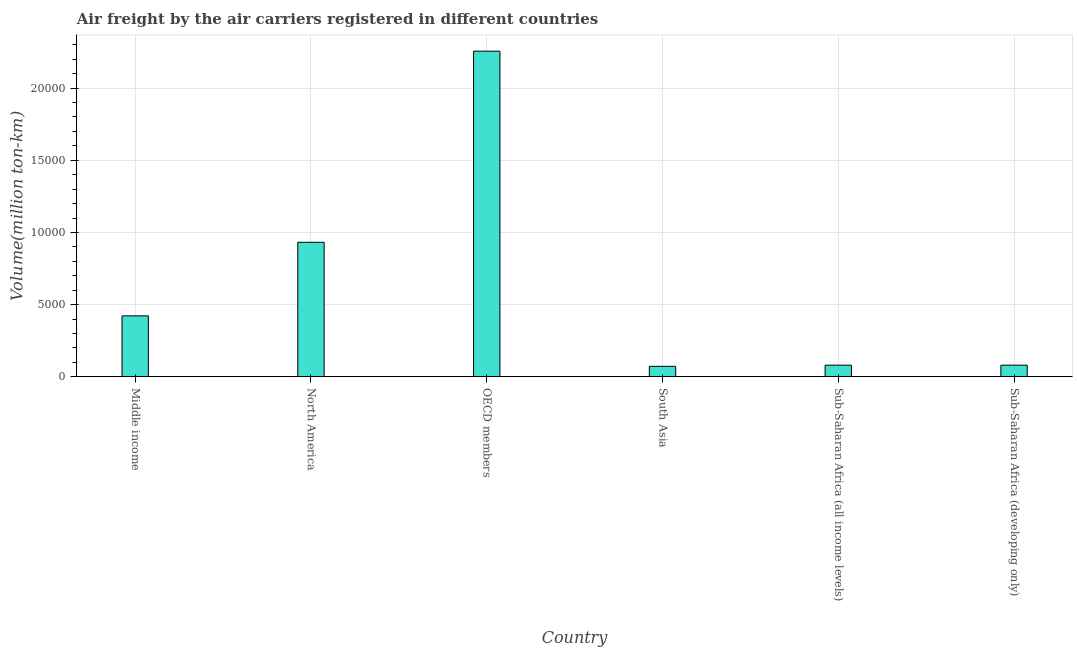Does the graph contain any zero values?
Provide a short and direct response. No. Does the graph contain grids?
Your answer should be very brief. Yes. What is the title of the graph?
Offer a terse response. Air freight by the air carriers registered in different countries. What is the label or title of the X-axis?
Your response must be concise. Country. What is the label or title of the Y-axis?
Provide a succinct answer. Volume(million ton-km). What is the air freight in Sub-Saharan Africa (developing only)?
Offer a terse response. 810.7. Across all countries, what is the maximum air freight?
Offer a terse response. 2.26e+04. Across all countries, what is the minimum air freight?
Keep it short and to the point. 729.2. In which country was the air freight maximum?
Keep it short and to the point. OECD members. In which country was the air freight minimum?
Make the answer very short. South Asia. What is the sum of the air freight?
Make the answer very short. 3.85e+04. What is the difference between the air freight in OECD members and Sub-Saharan Africa (developing only)?
Provide a short and direct response. 2.17e+04. What is the average air freight per country?
Your response must be concise. 6408.45. What is the median air freight?
Make the answer very short. 2517.85. What is the ratio of the air freight in Middle income to that in Sub-Saharan Africa (all income levels)?
Keep it short and to the point. 5.21. Is the air freight in Middle income less than that in North America?
Provide a succinct answer. Yes. Is the difference between the air freight in North America and South Asia greater than the difference between any two countries?
Give a very brief answer. No. What is the difference between the highest and the second highest air freight?
Keep it short and to the point. 1.32e+04. What is the difference between the highest and the lowest air freight?
Your answer should be compact. 2.18e+04. How many bars are there?
Give a very brief answer. 6. How many countries are there in the graph?
Provide a succinct answer. 6. Are the values on the major ticks of Y-axis written in scientific E-notation?
Ensure brevity in your answer.  No. What is the Volume(million ton-km) of Middle income?
Your answer should be very brief. 4224.9. What is the Volume(million ton-km) in North America?
Offer a terse response. 9320. What is the Volume(million ton-km) of OECD members?
Give a very brief answer. 2.26e+04. What is the Volume(million ton-km) in South Asia?
Keep it short and to the point. 729.2. What is the Volume(million ton-km) in Sub-Saharan Africa (all income levels)?
Offer a very short reply. 810.8. What is the Volume(million ton-km) of Sub-Saharan Africa (developing only)?
Keep it short and to the point. 810.7. What is the difference between the Volume(million ton-km) in Middle income and North America?
Ensure brevity in your answer.  -5095.1. What is the difference between the Volume(million ton-km) in Middle income and OECD members?
Your response must be concise. -1.83e+04. What is the difference between the Volume(million ton-km) in Middle income and South Asia?
Offer a terse response. 3495.7. What is the difference between the Volume(million ton-km) in Middle income and Sub-Saharan Africa (all income levels)?
Ensure brevity in your answer.  3414.1. What is the difference between the Volume(million ton-km) in Middle income and Sub-Saharan Africa (developing only)?
Keep it short and to the point. 3414.2. What is the difference between the Volume(million ton-km) in North America and OECD members?
Provide a short and direct response. -1.32e+04. What is the difference between the Volume(million ton-km) in North America and South Asia?
Provide a short and direct response. 8590.8. What is the difference between the Volume(million ton-km) in North America and Sub-Saharan Africa (all income levels)?
Provide a short and direct response. 8509.2. What is the difference between the Volume(million ton-km) in North America and Sub-Saharan Africa (developing only)?
Provide a succinct answer. 8509.3. What is the difference between the Volume(million ton-km) in OECD members and South Asia?
Make the answer very short. 2.18e+04. What is the difference between the Volume(million ton-km) in OECD members and Sub-Saharan Africa (all income levels)?
Your answer should be very brief. 2.17e+04. What is the difference between the Volume(million ton-km) in OECD members and Sub-Saharan Africa (developing only)?
Provide a succinct answer. 2.17e+04. What is the difference between the Volume(million ton-km) in South Asia and Sub-Saharan Africa (all income levels)?
Your response must be concise. -81.6. What is the difference between the Volume(million ton-km) in South Asia and Sub-Saharan Africa (developing only)?
Your answer should be very brief. -81.5. What is the ratio of the Volume(million ton-km) in Middle income to that in North America?
Provide a succinct answer. 0.45. What is the ratio of the Volume(million ton-km) in Middle income to that in OECD members?
Make the answer very short. 0.19. What is the ratio of the Volume(million ton-km) in Middle income to that in South Asia?
Keep it short and to the point. 5.79. What is the ratio of the Volume(million ton-km) in Middle income to that in Sub-Saharan Africa (all income levels)?
Keep it short and to the point. 5.21. What is the ratio of the Volume(million ton-km) in Middle income to that in Sub-Saharan Africa (developing only)?
Provide a short and direct response. 5.21. What is the ratio of the Volume(million ton-km) in North America to that in OECD members?
Your answer should be very brief. 0.41. What is the ratio of the Volume(million ton-km) in North America to that in South Asia?
Provide a succinct answer. 12.78. What is the ratio of the Volume(million ton-km) in North America to that in Sub-Saharan Africa (all income levels)?
Offer a very short reply. 11.49. What is the ratio of the Volume(million ton-km) in North America to that in Sub-Saharan Africa (developing only)?
Offer a terse response. 11.5. What is the ratio of the Volume(million ton-km) in OECD members to that in South Asia?
Offer a terse response. 30.93. What is the ratio of the Volume(million ton-km) in OECD members to that in Sub-Saharan Africa (all income levels)?
Provide a short and direct response. 27.82. What is the ratio of the Volume(million ton-km) in OECD members to that in Sub-Saharan Africa (developing only)?
Offer a very short reply. 27.82. What is the ratio of the Volume(million ton-km) in South Asia to that in Sub-Saharan Africa (all income levels)?
Provide a succinct answer. 0.9. What is the ratio of the Volume(million ton-km) in South Asia to that in Sub-Saharan Africa (developing only)?
Provide a short and direct response. 0.9. 